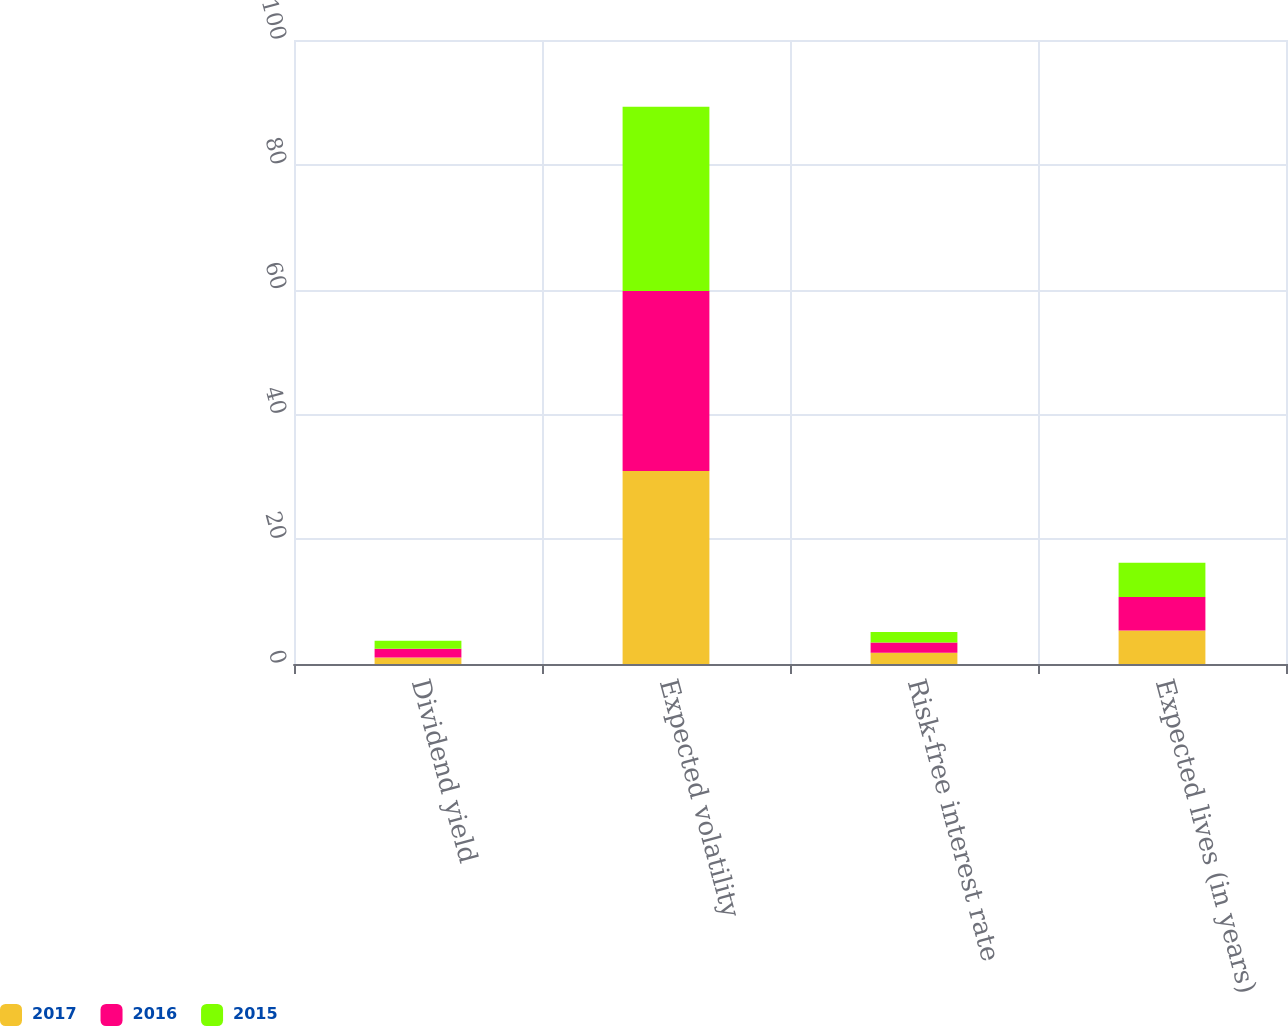Convert chart to OTSL. <chart><loc_0><loc_0><loc_500><loc_500><stacked_bar_chart><ecel><fcel>Dividend yield<fcel>Expected volatility<fcel>Risk-free interest rate<fcel>Expected lives (in years)<nl><fcel>2017<fcel>1.03<fcel>30.91<fcel>1.81<fcel>5.36<nl><fcel>2016<fcel>1.41<fcel>28.85<fcel>1.65<fcel>5.37<nl><fcel>2015<fcel>1.3<fcel>29.55<fcel>1.66<fcel>5.48<nl></chart> 